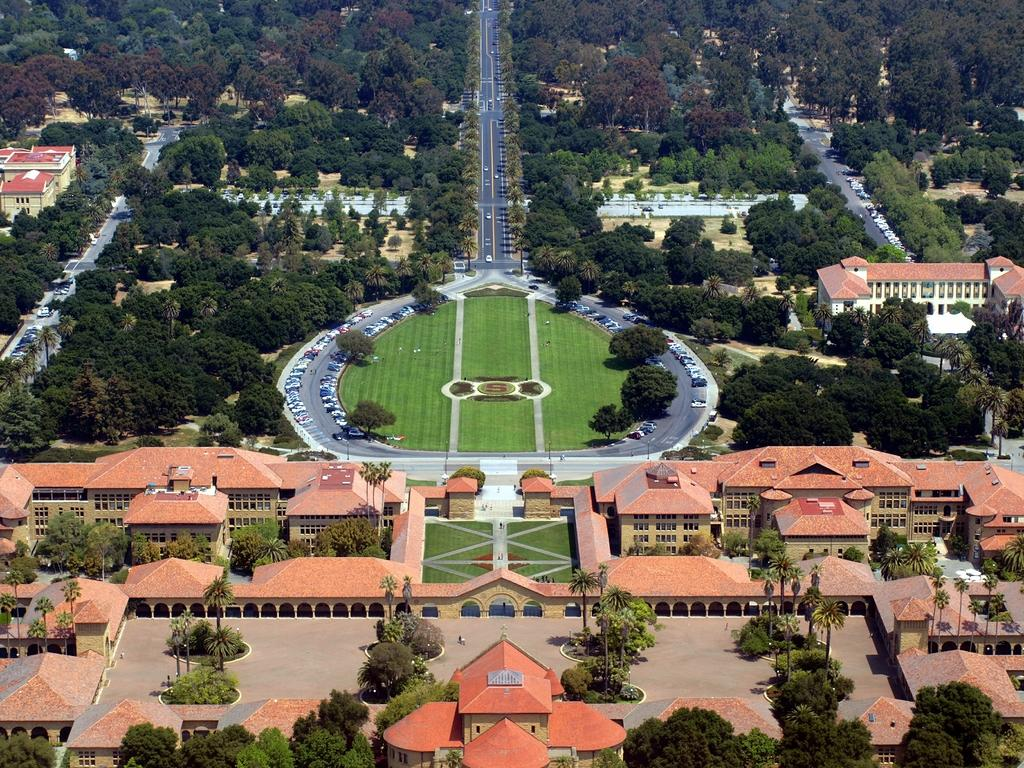What type of structures can be seen in the image? There are buildings in the image. What is the color and texture of the ground in the image? There is green grass in the image. What type of vegetation is present in the image? There are trees in the image. What type of pathway is visible in the image? There is a road visible in the image. Can you see a ship sailing on the grass in the image? No, there is no ship present in the image, and the grass is not a body of water for a ship to sail on. 